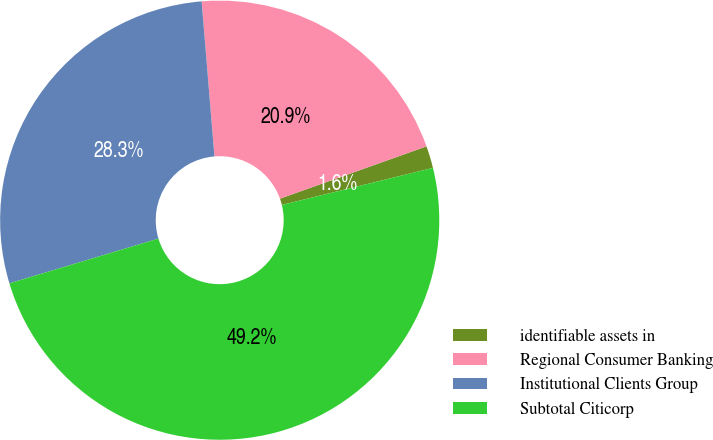Convert chart to OTSL. <chart><loc_0><loc_0><loc_500><loc_500><pie_chart><fcel>identifiable assets in<fcel>Regional Consumer Banking<fcel>Institutional Clients Group<fcel>Subtotal Citicorp<nl><fcel>1.63%<fcel>20.85%<fcel>28.33%<fcel>49.18%<nl></chart> 